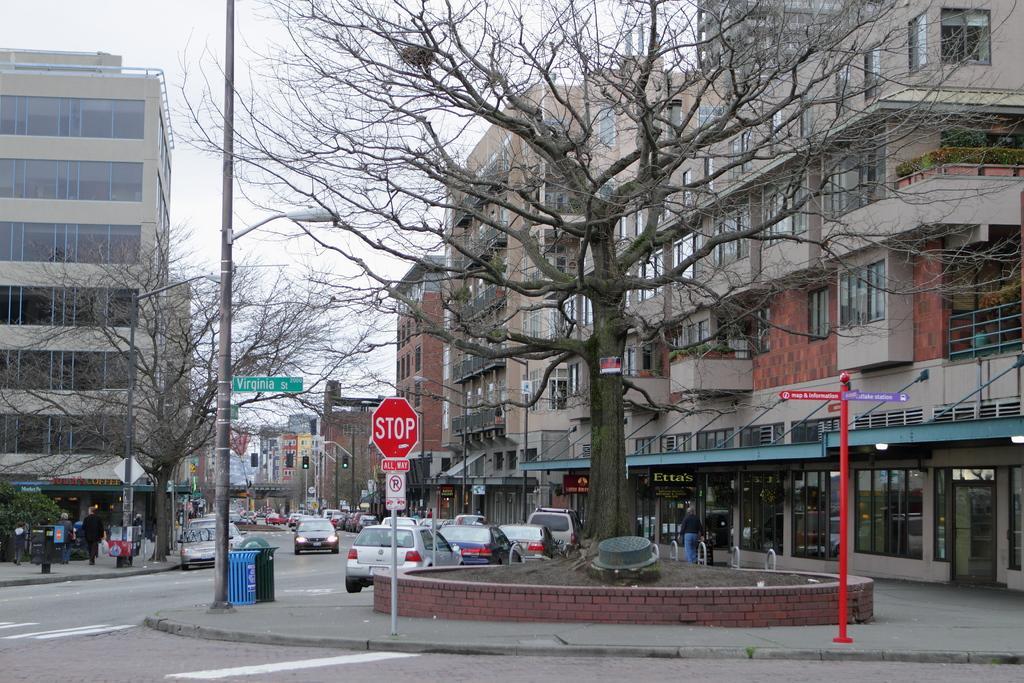Can you describe this image briefly? In this image I can see few vehicles on the road. In front I can see few boards attached to the poles, background I can see few dried trees and few trees in green color, buildings in cream, brown and white color, a light pole and the sky is in white color. 